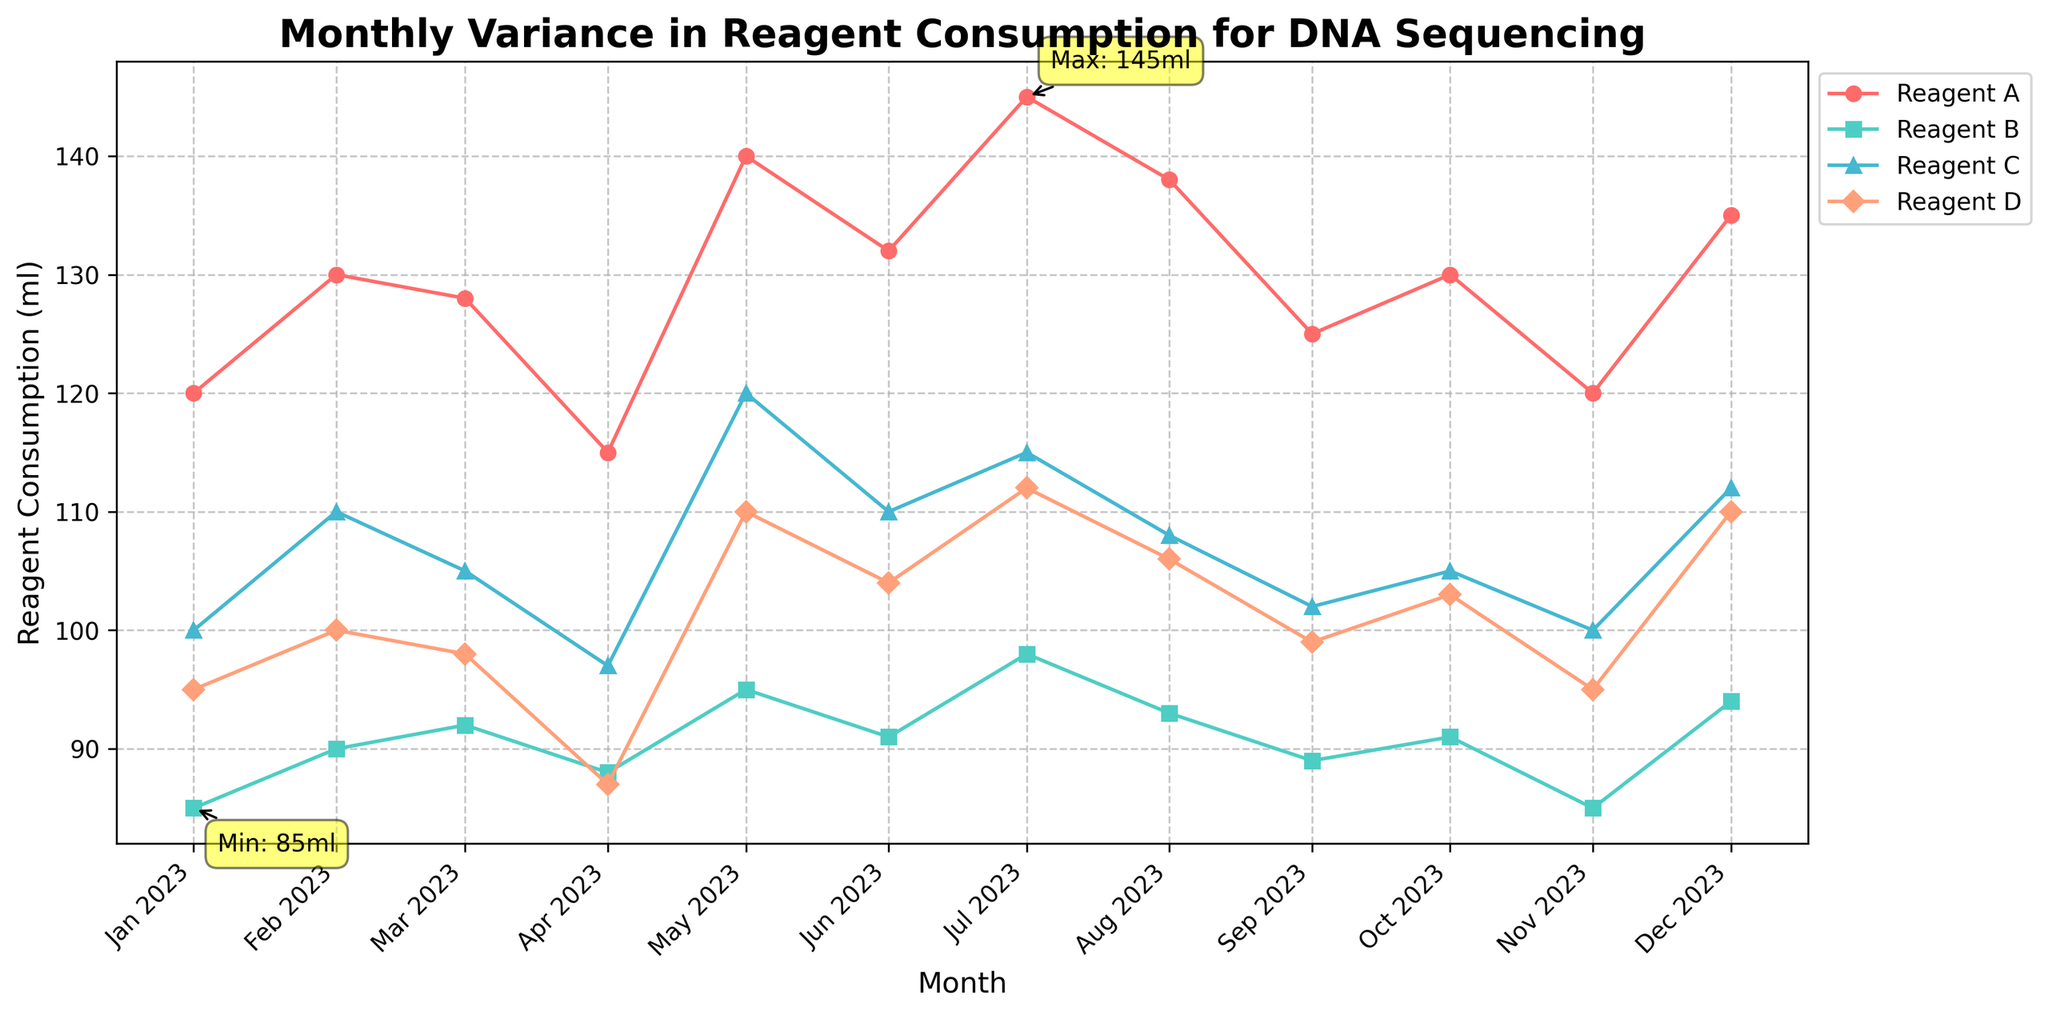What is the title of the plot? The title is usually at the top of the plot. In this case, it reads "Monthly Variance in Reagent Consumption for DNA Sequencing".
Answer: Monthly Variance in Reagent Consumption for DNA Sequencing Which month shows the highest total reagent consumption? By looking at the data and the figure, the highest total consumption is in July (2023-07) with the maximum combined reagent values.
Answer: July What is the general trend of Reagent A consumption from June to August? From the figure, Reagent A consumption is plotted using distinct markers and can be observed increasing from June to August.
Answer: Increasing Which month has the lowest Reagent D consumption? Refer to the plot where Reagent D's lowest value can be visualized. In April (2023-04), Reagent D has the lowest value of 87 ml.
Answer: April How does the trend of Reagent B compare to Reagent C over the year? By observing the plot lines, Reagent B and Reagent C both show a relatively stable trend with slight fluctuations, but Reagent B tends to be slightly lower throughout the year.
Answer: Reagent B is slightly lower What is the difference in total reagent consumption between the highest and lowest months? From the table, the highest total consumption is 470 ml in July and the lowest is 387 ml in April. Subtract 387 from 470 to get the difference.
Answer: 83 ml Between which two consecutive months does Reagent A show the maximum increase? Observe the plot for sharp rises in Reagent A. The increase from April (115 ml) to May (140 ml) is the largest.
Answer: April to May Which reagent shows the most variation throughout the year? By comparing the spread of data points for each reagent over the year, Reagent D appears to have the most variation.
Answer: Reagent D What is the average consumption of Reagent C over the 12 months? Sum all the Reagent C values from the data table and divide by 12. (100 + 110 + 105 + 97 + 120 + 110 + 115 + 108 + 102 + 105 + 100 + 112) / 12 = 1100 / 12
Answer: 108.33 ml In which month are all reagents’ consumptions equal? In February (2023-02), all consumptions are higher, but no month shows equal consumption for all reagents visually or in the data table.
Answer: None 